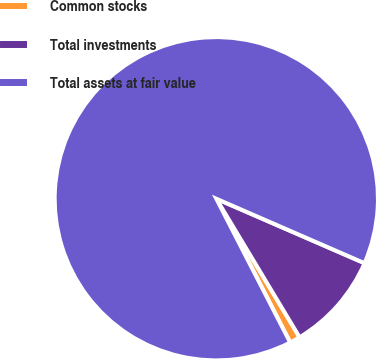Convert chart to OTSL. <chart><loc_0><loc_0><loc_500><loc_500><pie_chart><fcel>Common stocks<fcel>Total investments<fcel>Total assets at fair value<nl><fcel>1.06%<fcel>9.86%<fcel>89.08%<nl></chart> 